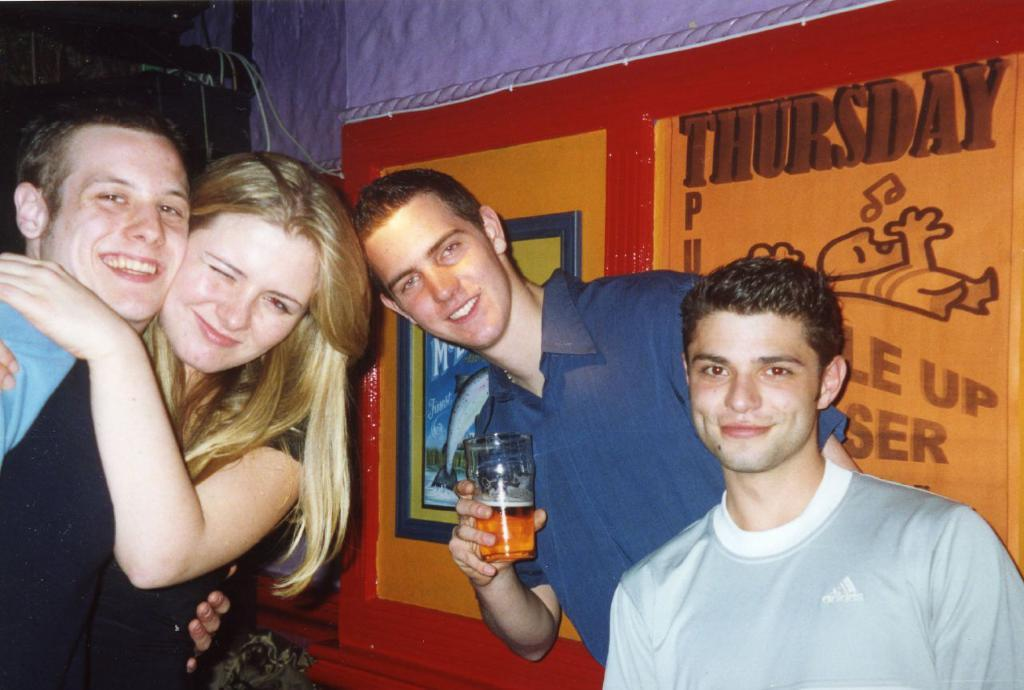How many people are present in the image? There are four people in the image: three men and one woman. What are the people in the image doing? The woman and men are standing. What can be seen in the background of the image? There is a banner in the background of the image. How are the people in the image sorting their agreements? There is no indication in the image that the people are sorting agreements or that they have any agreements to sort. --- Facts: 1. There is a car in the image. 2. The car is parked on the street. 3. There are trees on both sides of the street. 4. The sky is visible in the image. Absurd Topics: dance, fish, ocean Conversation: What is the main subject of the image? The main subject of the image is a car. Where is the car located in the image? The car is parked on the street. What can be seen on both sides of the street in the image? There are trees on both sides of the street. What is visible at the top of the image? The sky is visible in the image. Reasoning: Let's think step by step in order to produce the conversation. We start by identifying the main subject of the image, which is the car. Then, we describe its location, noting that it is parked on the street. Next, we mention the presence of trees on both sides of the street, which provides context for the setting. Finally, we acknowledge the presence of the sky, which is visible at the top of the image. Absurd Question/Answer: Can you see the fish swimming in the ocean in the image? There is no ocean or fish present in the image; it features a car parked on the street with trees on both sides. 